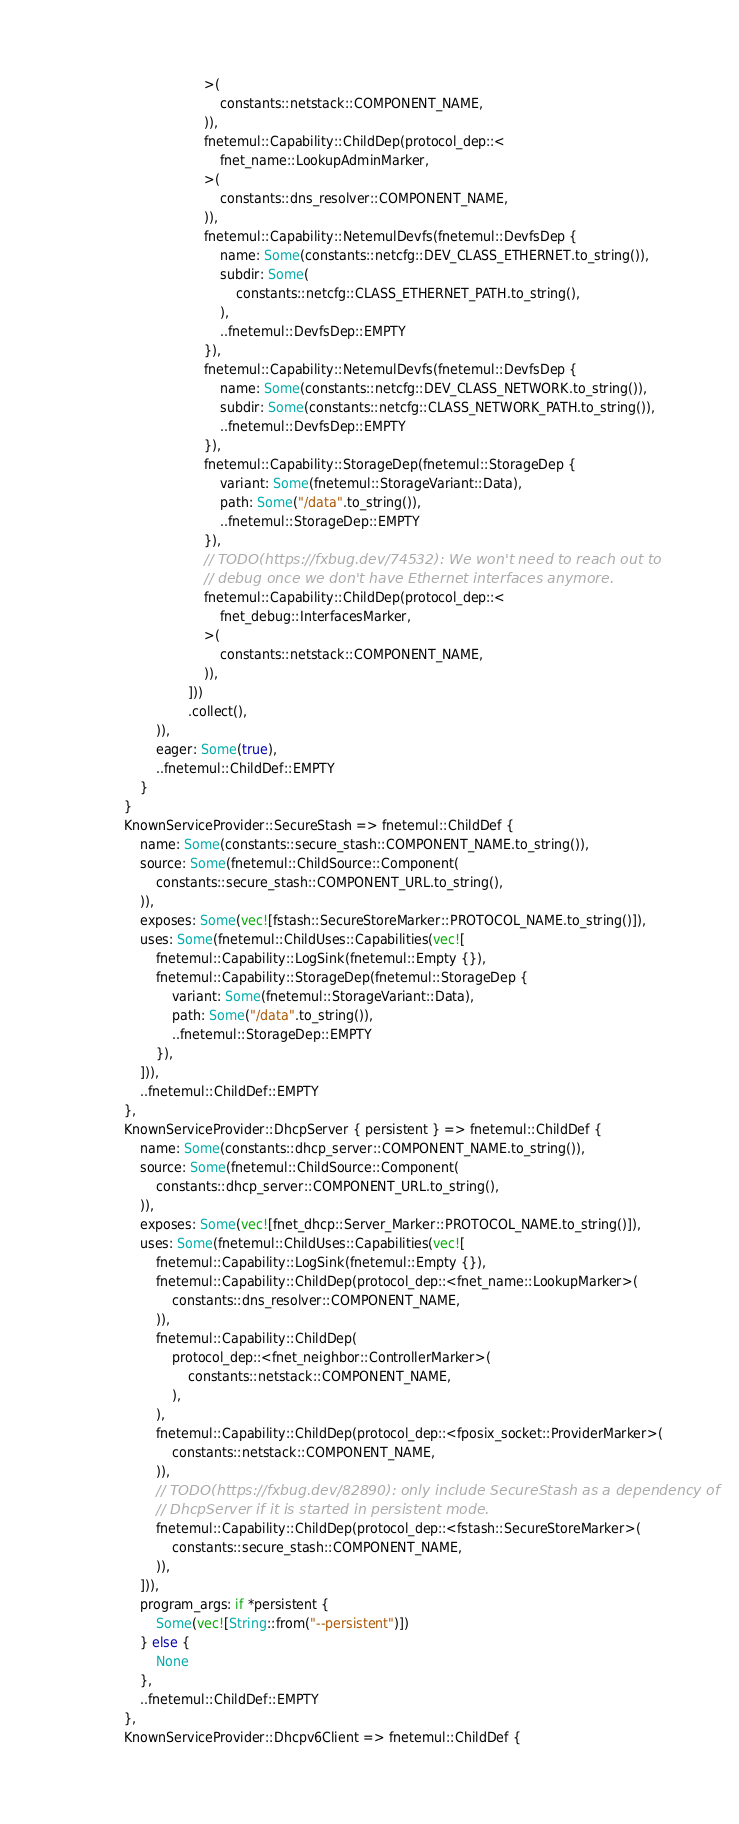<code> <loc_0><loc_0><loc_500><loc_500><_Rust_>                                >(
                                    constants::netstack::COMPONENT_NAME,
                                )),
                                fnetemul::Capability::ChildDep(protocol_dep::<
                                    fnet_name::LookupAdminMarker,
                                >(
                                    constants::dns_resolver::COMPONENT_NAME,
                                )),
                                fnetemul::Capability::NetemulDevfs(fnetemul::DevfsDep {
                                    name: Some(constants::netcfg::DEV_CLASS_ETHERNET.to_string()),
                                    subdir: Some(
                                        constants::netcfg::CLASS_ETHERNET_PATH.to_string(),
                                    ),
                                    ..fnetemul::DevfsDep::EMPTY
                                }),
                                fnetemul::Capability::NetemulDevfs(fnetemul::DevfsDep {
                                    name: Some(constants::netcfg::DEV_CLASS_NETWORK.to_string()),
                                    subdir: Some(constants::netcfg::CLASS_NETWORK_PATH.to_string()),
                                    ..fnetemul::DevfsDep::EMPTY
                                }),
                                fnetemul::Capability::StorageDep(fnetemul::StorageDep {
                                    variant: Some(fnetemul::StorageVariant::Data),
                                    path: Some("/data".to_string()),
                                    ..fnetemul::StorageDep::EMPTY
                                }),
                                // TODO(https://fxbug.dev/74532): We won't need to reach out to
                                // debug once we don't have Ethernet interfaces anymore.
                                fnetemul::Capability::ChildDep(protocol_dep::<
                                    fnet_debug::InterfacesMarker,
                                >(
                                    constants::netstack::COMPONENT_NAME,
                                )),
                            ]))
                            .collect(),
                    )),
                    eager: Some(true),
                    ..fnetemul::ChildDef::EMPTY
                }
            }
            KnownServiceProvider::SecureStash => fnetemul::ChildDef {
                name: Some(constants::secure_stash::COMPONENT_NAME.to_string()),
                source: Some(fnetemul::ChildSource::Component(
                    constants::secure_stash::COMPONENT_URL.to_string(),
                )),
                exposes: Some(vec![fstash::SecureStoreMarker::PROTOCOL_NAME.to_string()]),
                uses: Some(fnetemul::ChildUses::Capabilities(vec![
                    fnetemul::Capability::LogSink(fnetemul::Empty {}),
                    fnetemul::Capability::StorageDep(fnetemul::StorageDep {
                        variant: Some(fnetemul::StorageVariant::Data),
                        path: Some("/data".to_string()),
                        ..fnetemul::StorageDep::EMPTY
                    }),
                ])),
                ..fnetemul::ChildDef::EMPTY
            },
            KnownServiceProvider::DhcpServer { persistent } => fnetemul::ChildDef {
                name: Some(constants::dhcp_server::COMPONENT_NAME.to_string()),
                source: Some(fnetemul::ChildSource::Component(
                    constants::dhcp_server::COMPONENT_URL.to_string(),
                )),
                exposes: Some(vec![fnet_dhcp::Server_Marker::PROTOCOL_NAME.to_string()]),
                uses: Some(fnetemul::ChildUses::Capabilities(vec![
                    fnetemul::Capability::LogSink(fnetemul::Empty {}),
                    fnetemul::Capability::ChildDep(protocol_dep::<fnet_name::LookupMarker>(
                        constants::dns_resolver::COMPONENT_NAME,
                    )),
                    fnetemul::Capability::ChildDep(
                        protocol_dep::<fnet_neighbor::ControllerMarker>(
                            constants::netstack::COMPONENT_NAME,
                        ),
                    ),
                    fnetemul::Capability::ChildDep(protocol_dep::<fposix_socket::ProviderMarker>(
                        constants::netstack::COMPONENT_NAME,
                    )),
                    // TODO(https://fxbug.dev/82890): only include SecureStash as a dependency of
                    // DhcpServer if it is started in persistent mode.
                    fnetemul::Capability::ChildDep(protocol_dep::<fstash::SecureStoreMarker>(
                        constants::secure_stash::COMPONENT_NAME,
                    )),
                ])),
                program_args: if *persistent {
                    Some(vec![String::from("--persistent")])
                } else {
                    None
                },
                ..fnetemul::ChildDef::EMPTY
            },
            KnownServiceProvider::Dhcpv6Client => fnetemul::ChildDef {</code> 